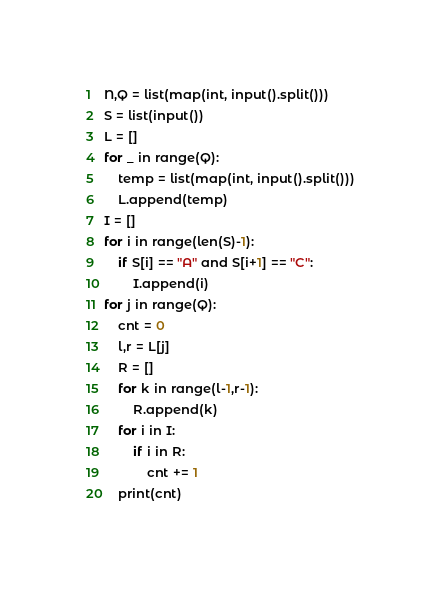<code> <loc_0><loc_0><loc_500><loc_500><_Python_>N,Q = list(map(int, input().split()))
S = list(input())
L = []
for _ in range(Q):
    temp = list(map(int, input().split()))
    L.append(temp)
I = []
for i in range(len(S)-1):
    if S[i] == "A" and S[i+1] == "C":
        I.append(i)
for j in range(Q):
    cnt = 0
    l,r = L[j]
    R = []
    for k in range(l-1,r-1):
        R.append(k)
    for i in I:
        if i in R:
            cnt += 1
    print(cnt)</code> 